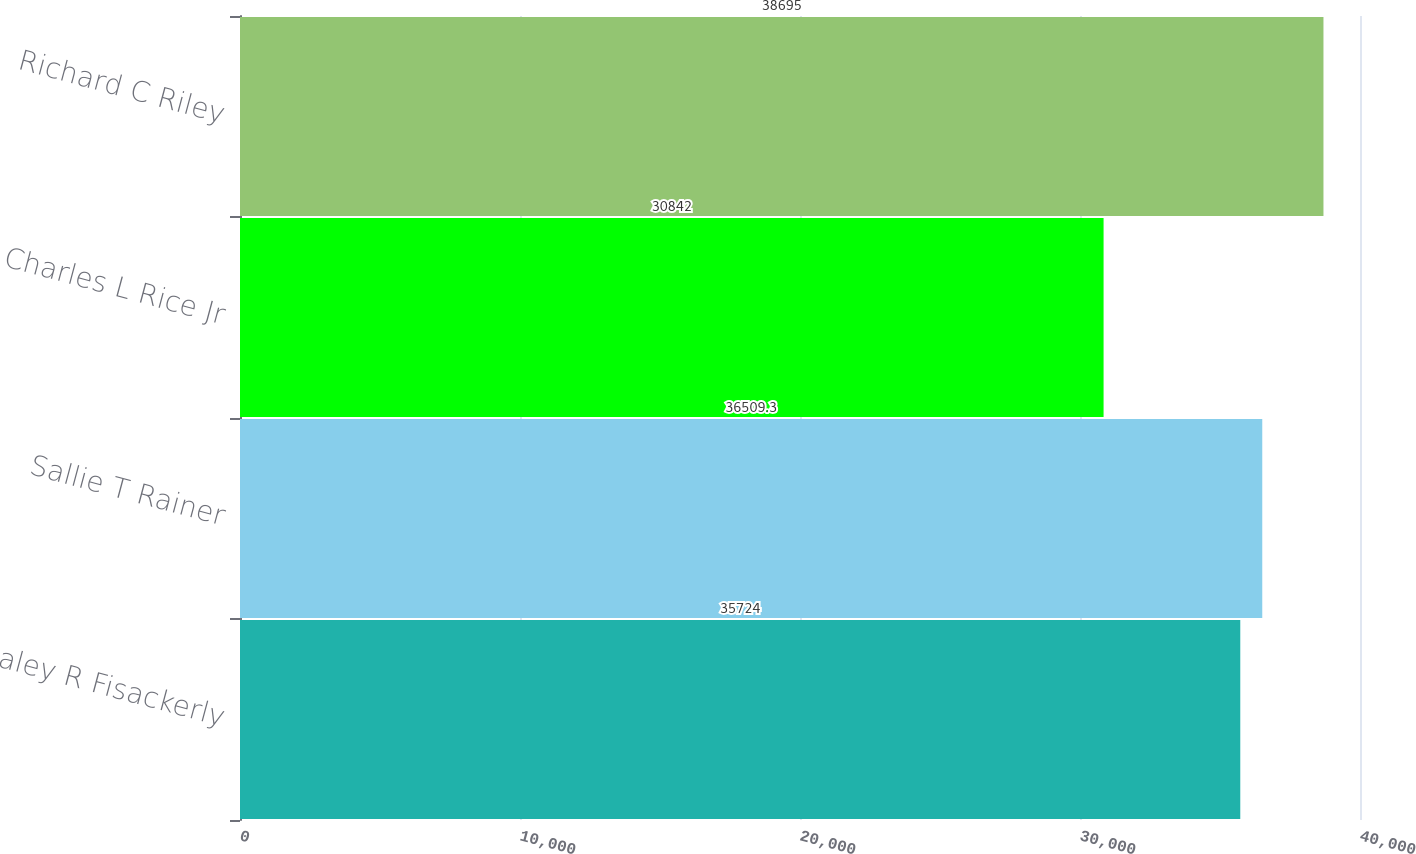Convert chart. <chart><loc_0><loc_0><loc_500><loc_500><bar_chart><fcel>Haley R Fisackerly<fcel>Sallie T Rainer<fcel>Charles L Rice Jr<fcel>Richard C Riley<nl><fcel>35724<fcel>36509.3<fcel>30842<fcel>38695<nl></chart> 